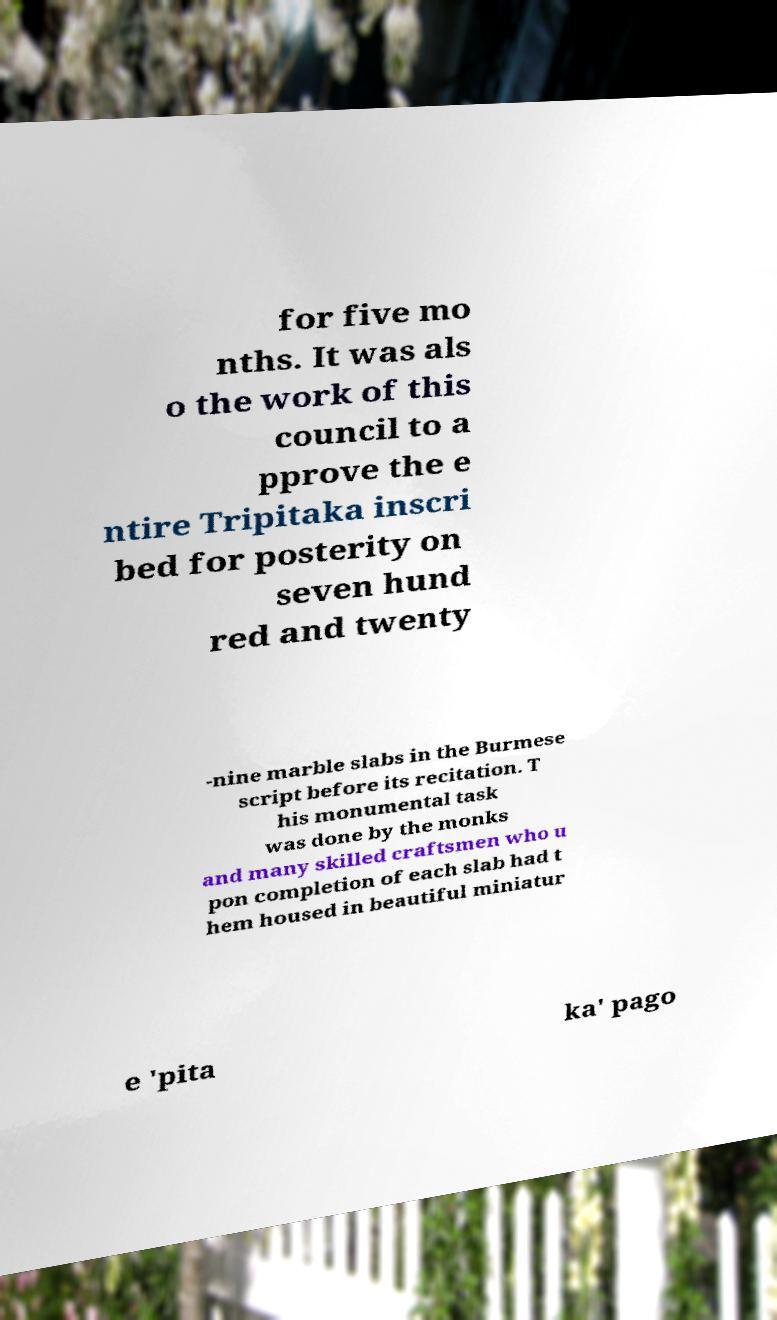Could you assist in decoding the text presented in this image and type it out clearly? for five mo nths. It was als o the work of this council to a pprove the e ntire Tripitaka inscri bed for posterity on seven hund red and twenty -nine marble slabs in the Burmese script before its recitation. T his monumental task was done by the monks and many skilled craftsmen who u pon completion of each slab had t hem housed in beautiful miniatur e 'pita ka' pago 